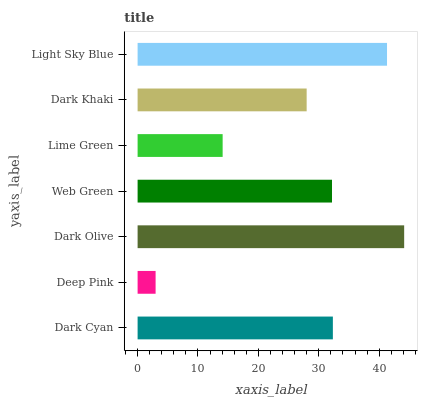Is Deep Pink the minimum?
Answer yes or no. Yes. Is Dark Olive the maximum?
Answer yes or no. Yes. Is Dark Olive the minimum?
Answer yes or no. No. Is Deep Pink the maximum?
Answer yes or no. No. Is Dark Olive greater than Deep Pink?
Answer yes or no. Yes. Is Deep Pink less than Dark Olive?
Answer yes or no. Yes. Is Deep Pink greater than Dark Olive?
Answer yes or no. No. Is Dark Olive less than Deep Pink?
Answer yes or no. No. Is Web Green the high median?
Answer yes or no. Yes. Is Web Green the low median?
Answer yes or no. Yes. Is Dark Olive the high median?
Answer yes or no. No. Is Deep Pink the low median?
Answer yes or no. No. 